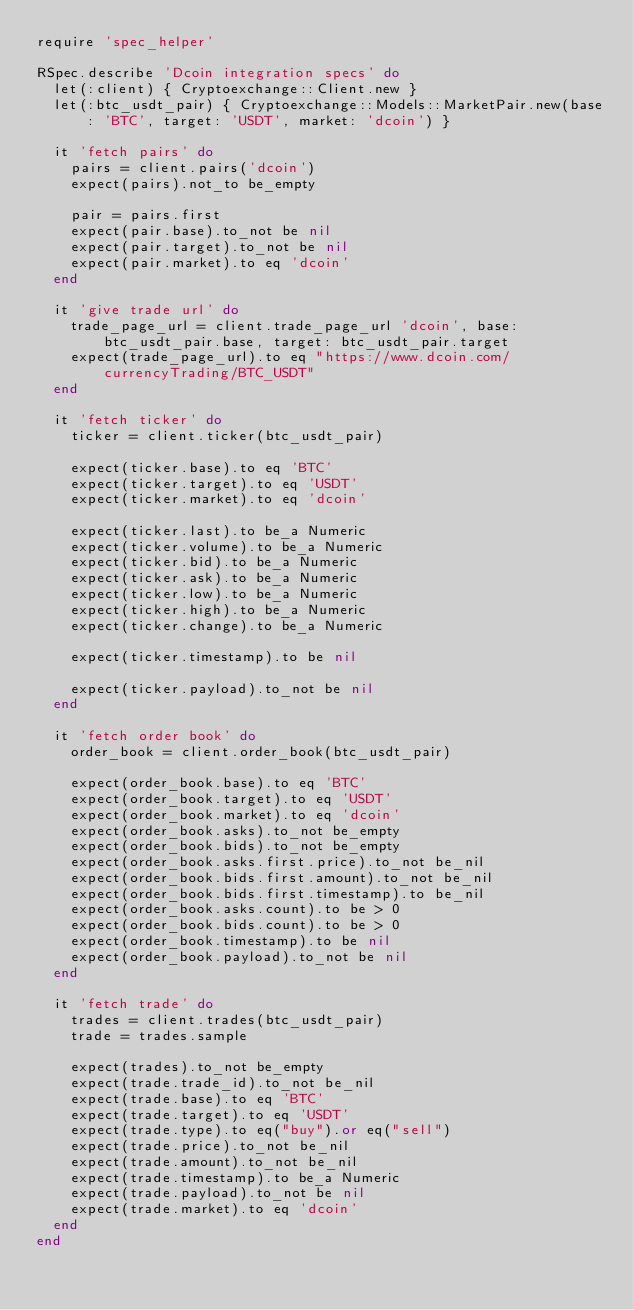Convert code to text. <code><loc_0><loc_0><loc_500><loc_500><_Ruby_>require 'spec_helper'

RSpec.describe 'Dcoin integration specs' do
  let(:client) { Cryptoexchange::Client.new }
  let(:btc_usdt_pair) { Cryptoexchange::Models::MarketPair.new(base: 'BTC', target: 'USDT', market: 'dcoin') }

  it 'fetch pairs' do
    pairs = client.pairs('dcoin')
    expect(pairs).not_to be_empty

    pair = pairs.first
    expect(pair.base).to_not be nil
    expect(pair.target).to_not be nil
    expect(pair.market).to eq 'dcoin'
  end

  it 'give trade url' do
    trade_page_url = client.trade_page_url 'dcoin', base: btc_usdt_pair.base, target: btc_usdt_pair.target
    expect(trade_page_url).to eq "https://www.dcoin.com/currencyTrading/BTC_USDT"
  end

  it 'fetch ticker' do
    ticker = client.ticker(btc_usdt_pair)

    expect(ticker.base).to eq 'BTC'
    expect(ticker.target).to eq 'USDT'
    expect(ticker.market).to eq 'dcoin'

    expect(ticker.last).to be_a Numeric
    expect(ticker.volume).to be_a Numeric
    expect(ticker.bid).to be_a Numeric
    expect(ticker.ask).to be_a Numeric
    expect(ticker.low).to be_a Numeric
    expect(ticker.high).to be_a Numeric
    expect(ticker.change).to be_a Numeric

    expect(ticker.timestamp).to be nil

    expect(ticker.payload).to_not be nil
  end

  it 'fetch order book' do
    order_book = client.order_book(btc_usdt_pair)

    expect(order_book.base).to eq 'BTC'
    expect(order_book.target).to eq 'USDT'
    expect(order_book.market).to eq 'dcoin'
    expect(order_book.asks).to_not be_empty
    expect(order_book.bids).to_not be_empty
    expect(order_book.asks.first.price).to_not be_nil
    expect(order_book.bids.first.amount).to_not be_nil
    expect(order_book.bids.first.timestamp).to be_nil
    expect(order_book.asks.count).to be > 0
    expect(order_book.bids.count).to be > 0
    expect(order_book.timestamp).to be nil
    expect(order_book.payload).to_not be nil
  end

  it 'fetch trade' do
    trades = client.trades(btc_usdt_pair)
    trade = trades.sample

    expect(trades).to_not be_empty
    expect(trade.trade_id).to_not be_nil
    expect(trade.base).to eq 'BTC'
    expect(trade.target).to eq 'USDT'
    expect(trade.type).to eq("buy").or eq("sell")
    expect(trade.price).to_not be_nil
    expect(trade.amount).to_not be_nil
    expect(trade.timestamp).to be_a Numeric
    expect(trade.payload).to_not be nil
    expect(trade.market).to eq 'dcoin'
  end
end
</code> 